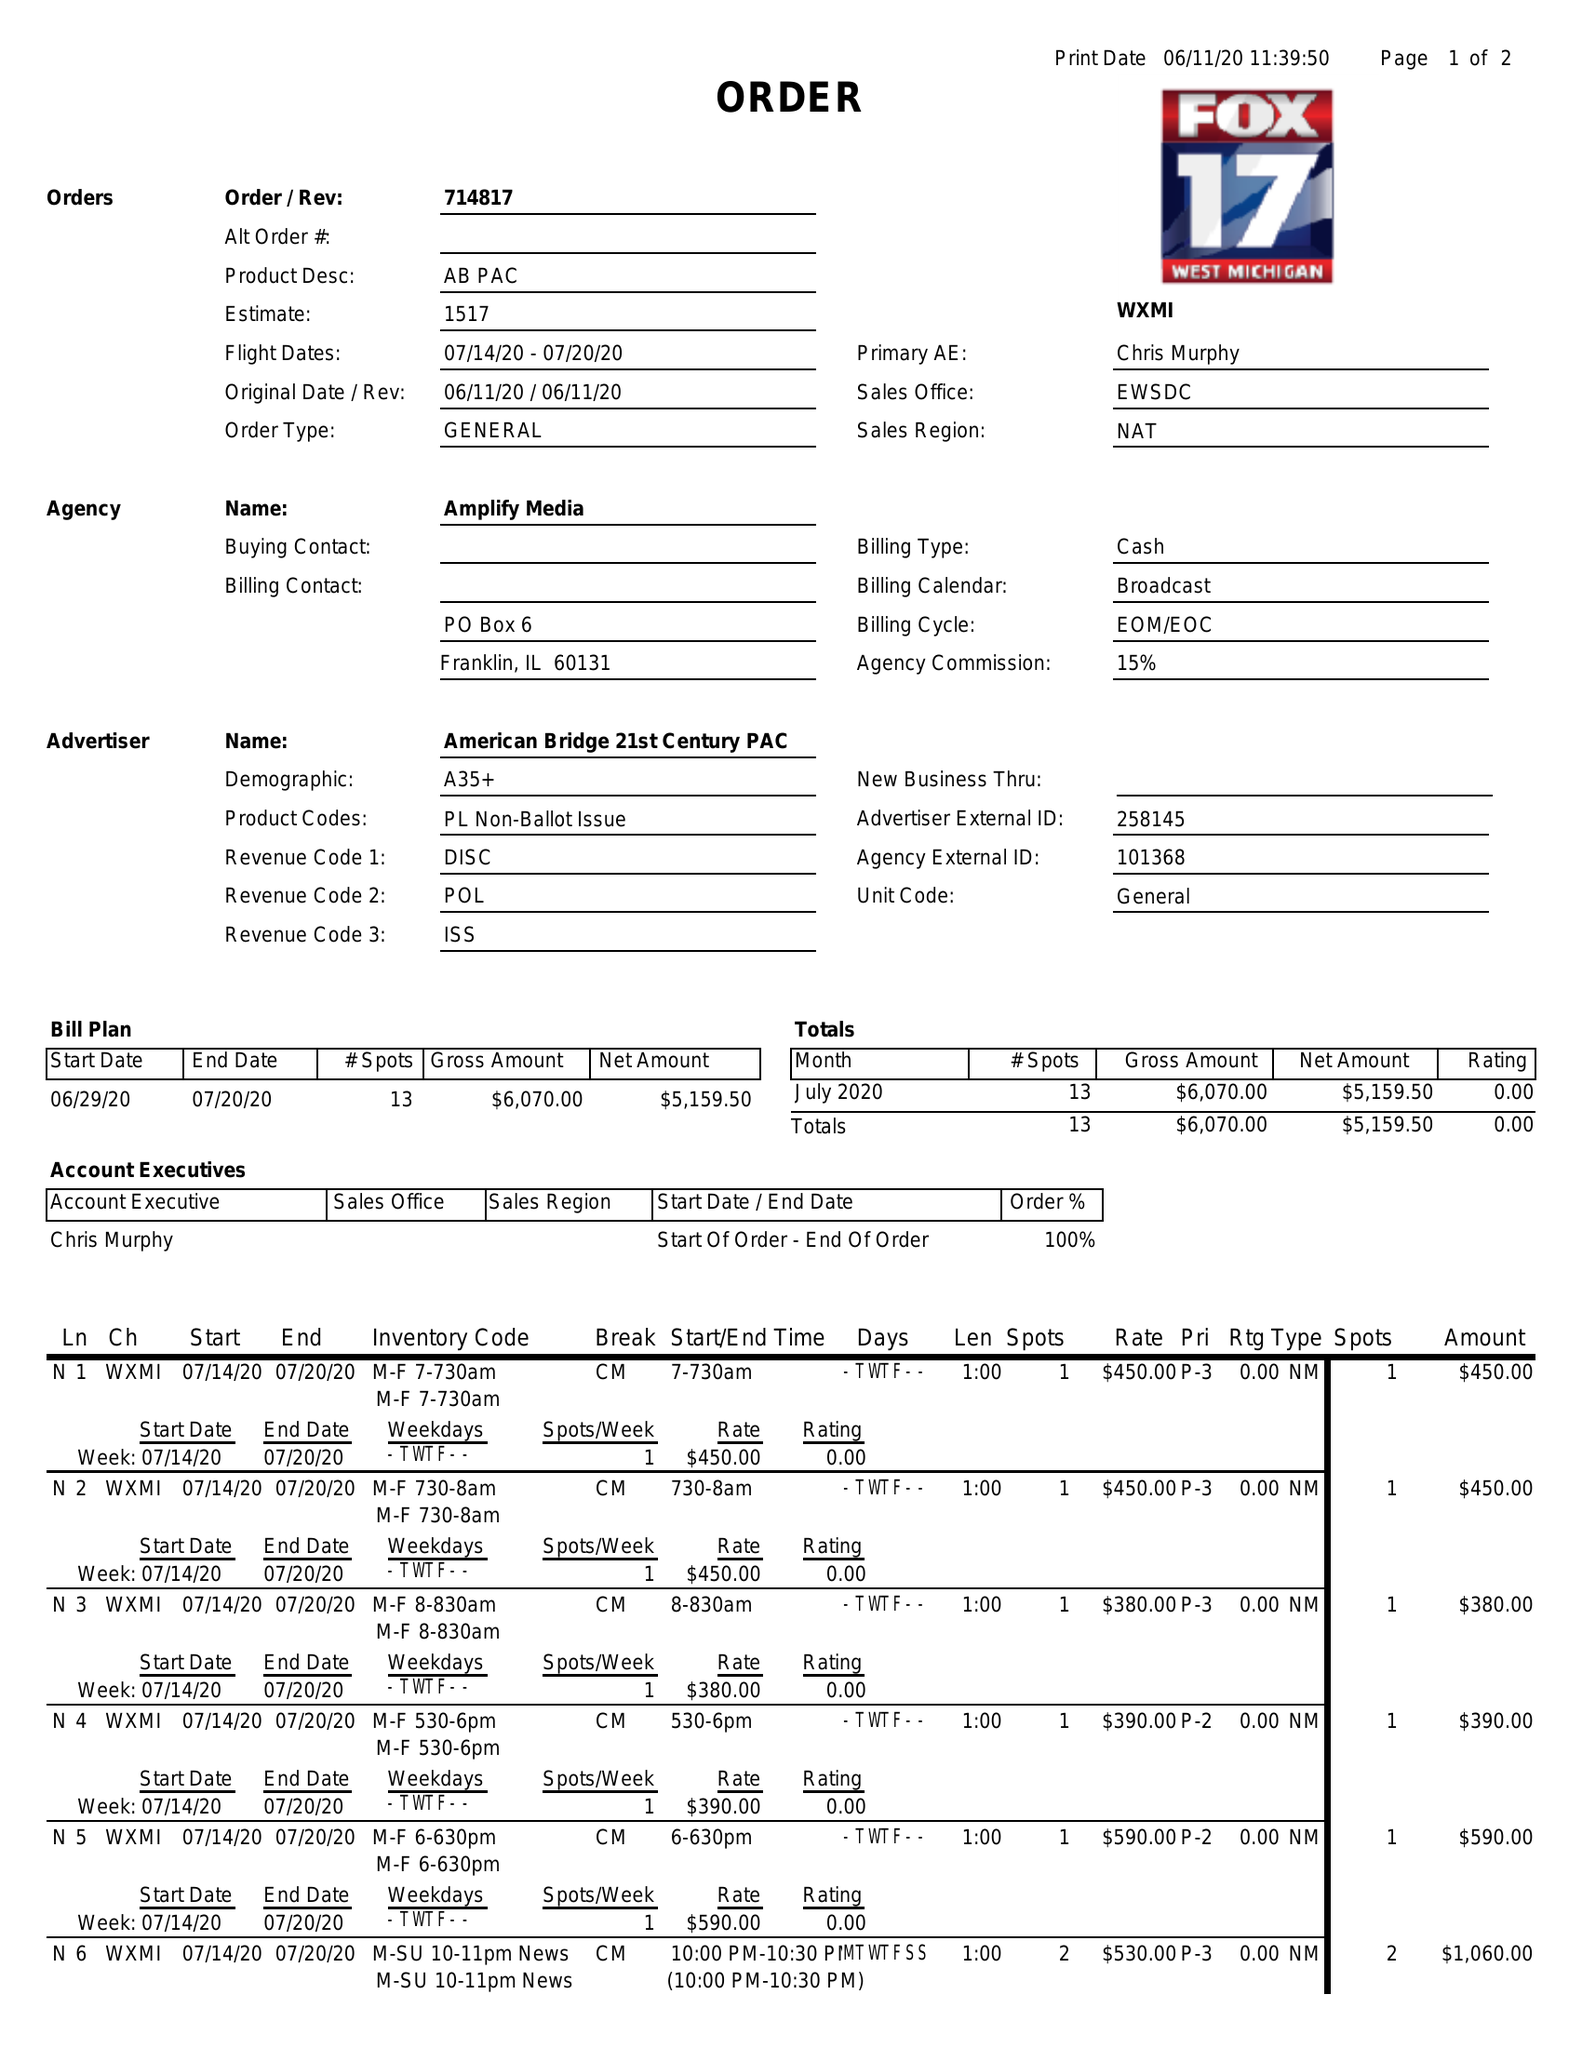What is the value for the flight_to?
Answer the question using a single word or phrase. 07/20/20 